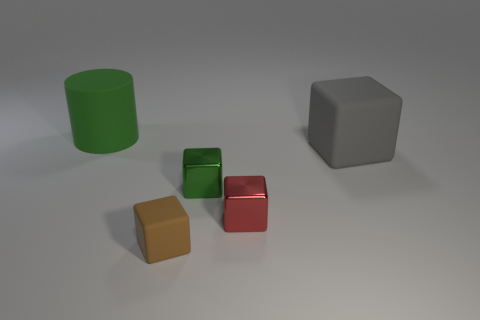Do the tiny metallic object that is behind the tiny red metallic cube and the big cylinder have the same color?
Offer a terse response. Yes. Is there a large cyan shiny cube?
Offer a terse response. No. How many other things are there of the same size as the green cylinder?
Your response must be concise. 1. There is a big thing to the left of the tiny rubber block; is its color the same as the small cube that is behind the red metal thing?
Offer a very short reply. Yes. What is the size of the red thing that is the same shape as the gray object?
Offer a terse response. Small. Are the green object that is in front of the matte cylinder and the tiny cube that is to the right of the green block made of the same material?
Provide a short and direct response. Yes. How many rubber objects are cubes or yellow spheres?
Ensure brevity in your answer.  2. There is a green thing in front of the green thing behind the large matte object that is to the right of the cylinder; what is its material?
Ensure brevity in your answer.  Metal. There is a large thing on the right side of the big green cylinder; does it have the same shape as the green thing in front of the green cylinder?
Your answer should be compact. Yes. The rubber cube that is in front of the big rubber thing that is in front of the green matte cylinder is what color?
Provide a succinct answer. Brown. 